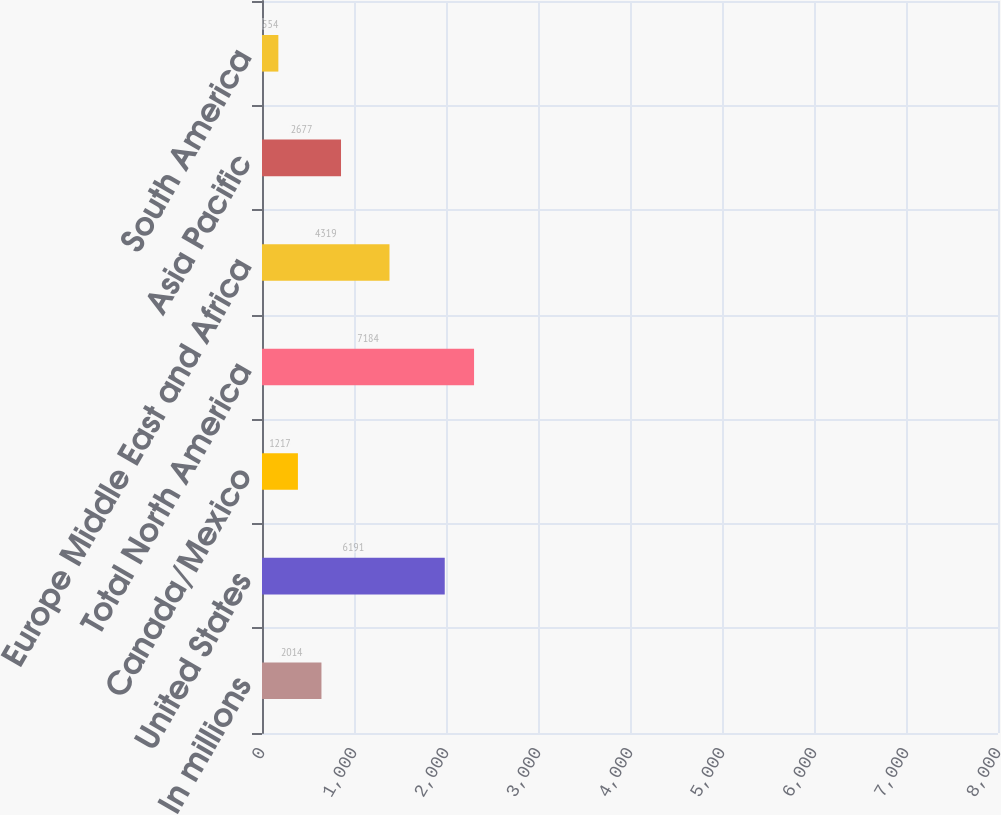Convert chart. <chart><loc_0><loc_0><loc_500><loc_500><bar_chart><fcel>In millions<fcel>United States<fcel>Canada/Mexico<fcel>Total North America<fcel>Europe Middle East and Africa<fcel>Asia Pacific<fcel>South America<nl><fcel>2014<fcel>6191<fcel>1217<fcel>7184<fcel>4319<fcel>2677<fcel>554<nl></chart> 